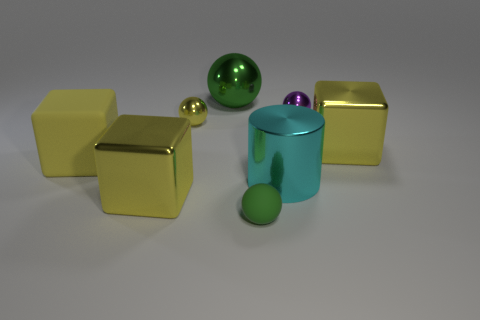How does the arrangement of objects in the image make you feel? The arrangement of objects, with their varying sizes and orderly spacing, conveys a sense of balance and intention. It evokes a feeling of calmness and order, with each item neatly placed in the space. 